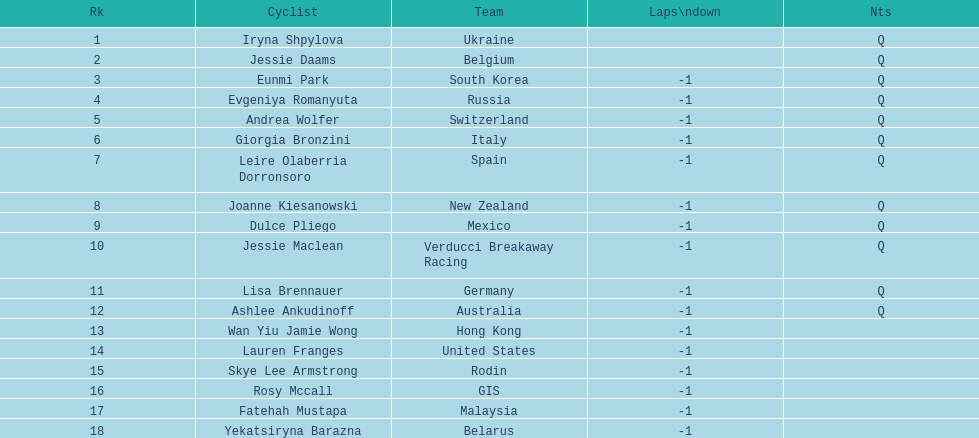Would you mind parsing the complete table? {'header': ['Rk', 'Cyclist', 'Team', 'Laps\\ndown', 'Nts'], 'rows': [['1', 'Iryna Shpylova', 'Ukraine', '', 'Q'], ['2', 'Jessie Daams', 'Belgium', '', 'Q'], ['3', 'Eunmi Park', 'South Korea', '-1', 'Q'], ['4', 'Evgeniya Romanyuta', 'Russia', '-1', 'Q'], ['5', 'Andrea Wolfer', 'Switzerland', '-1', 'Q'], ['6', 'Giorgia Bronzini', 'Italy', '-1', 'Q'], ['7', 'Leire Olaberria Dorronsoro', 'Spain', '-1', 'Q'], ['8', 'Joanne Kiesanowski', 'New Zealand', '-1', 'Q'], ['9', 'Dulce Pliego', 'Mexico', '-1', 'Q'], ['10', 'Jessie Maclean', 'Verducci Breakaway Racing', '-1', 'Q'], ['11', 'Lisa Brennauer', 'Germany', '-1', 'Q'], ['12', 'Ashlee Ankudinoff', 'Australia', '-1', 'Q'], ['13', 'Wan Yiu Jamie Wong', 'Hong Kong', '-1', ''], ['14', 'Lauren Franges', 'United States', '-1', ''], ['15', 'Skye Lee Armstrong', 'Rodin', '-1', ''], ['16', 'Rosy Mccall', 'GIS', '-1', ''], ['17', 'Fatehah Mustapa', 'Malaysia', '-1', ''], ['18', 'Yekatsiryna Barazna', 'Belarus', '-1', '']]} Which two bicyclists belong to teams with no laps behind? Iryna Shpylova, Jessie Daams. 